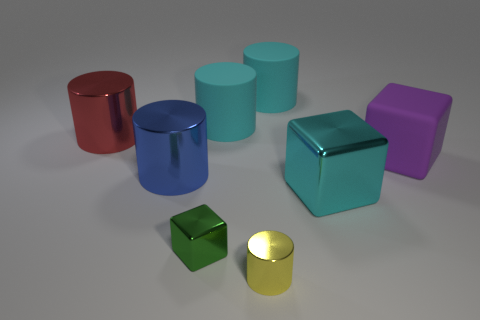Subtract all metallic cubes. How many cubes are left? 1 Subtract 2 cylinders. How many cylinders are left? 3 Subtract all red cylinders. How many cylinders are left? 4 Add 2 large metal blocks. How many objects exist? 10 Subtract all brown cylinders. Subtract all purple cubes. How many cylinders are left? 5 Subtract all cubes. How many objects are left? 5 Add 4 metallic cylinders. How many metallic cylinders are left? 7 Add 2 metallic cylinders. How many metallic cylinders exist? 5 Subtract 0 gray cylinders. How many objects are left? 8 Subtract all big green objects. Subtract all big metallic cubes. How many objects are left? 7 